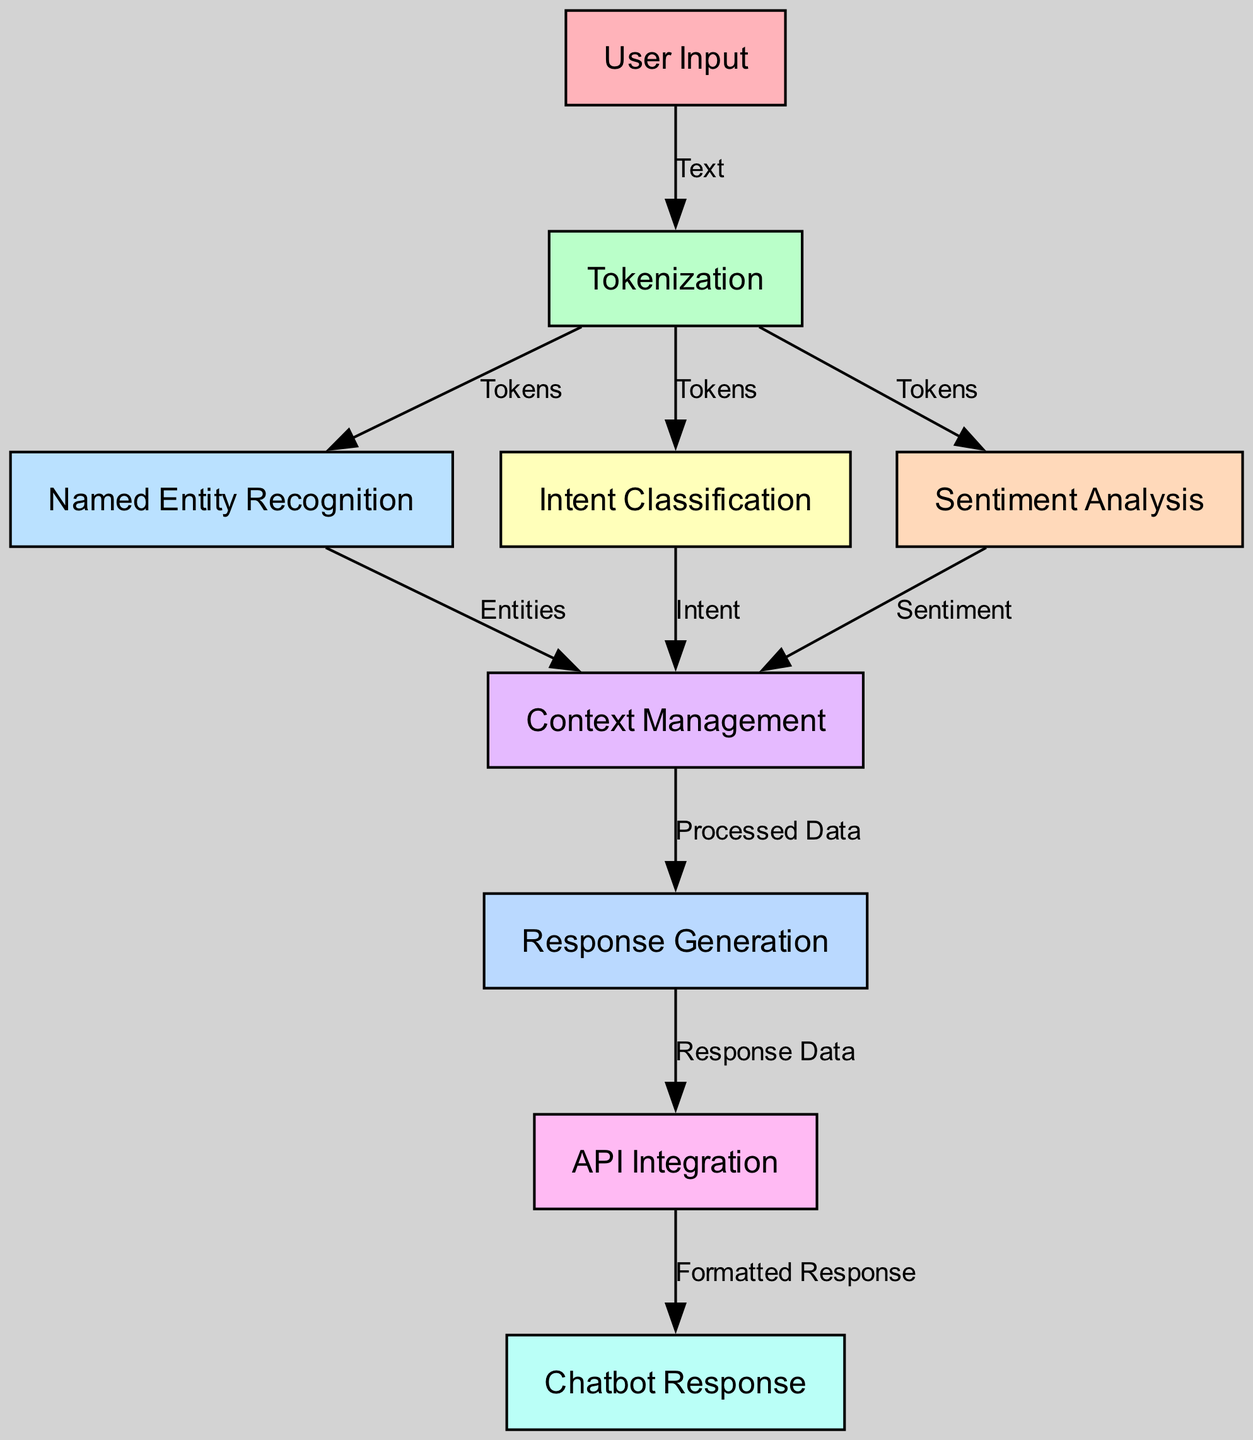What is the first step in the NLP pipeline? The first node in the diagram is labeled "User Input," which represents the initial step in the natural language processing pipeline.
Answer: User Input How many nodes are present in the diagram? By counting each of the labeled nodes in the `nodes` section of the provided data, we find there are a total of 9 nodes.
Answer: 9 What do tokens serve as in the connection between User Input and Tokenization? The edge connecting "User Input" to "Tokenization" is labeled "Text," indicating that the text provided by the user is tokenized in the next step.
Answer: Text Which node receives data from both Named Entity Recognition and Intent Classification? The node labeled "Context Management" receives processed information from both "Named Entity Recognition" and "Intent Classification," as indicated by the edges leading into it.
Answer: Context Management What is the final output generated in the NLP pipeline? The last node in the diagram is "Chatbot Response," which indicates that this is the final output that the user receives after processing.
Answer: Chatbot Response What types of analysis are performed concurrently after Tokenization? After "Tokenization," both "Named Entity Recognition" and "Intent Classification" nodes process the tokenized data at the same level, as shown by their direct connections from "Tokenization."
Answer: Named Entity Recognition and Intent Classification How does the processed data get to Response Generation? The edge from "Context Management" to "Response Generation" is labeled "Processed Data," indicating that the processed information is passed to this node for generating a response.
Answer: Processed Data Which step involves combining information from different analyses in the pipeline? The "Context Management" node involves combining various data inputs such as entities, intent, and sentiment analysis from the earlier steps of the pipeline to derive a contextually aware response.
Answer: Context Management What is the relationship between Response Generation and API Integration? The edge between "Response Generation" and "API Integration" is labeled "Response Data," indicating that the data generated for the response is sent to be integrated with the API next.
Answer: Response Data 